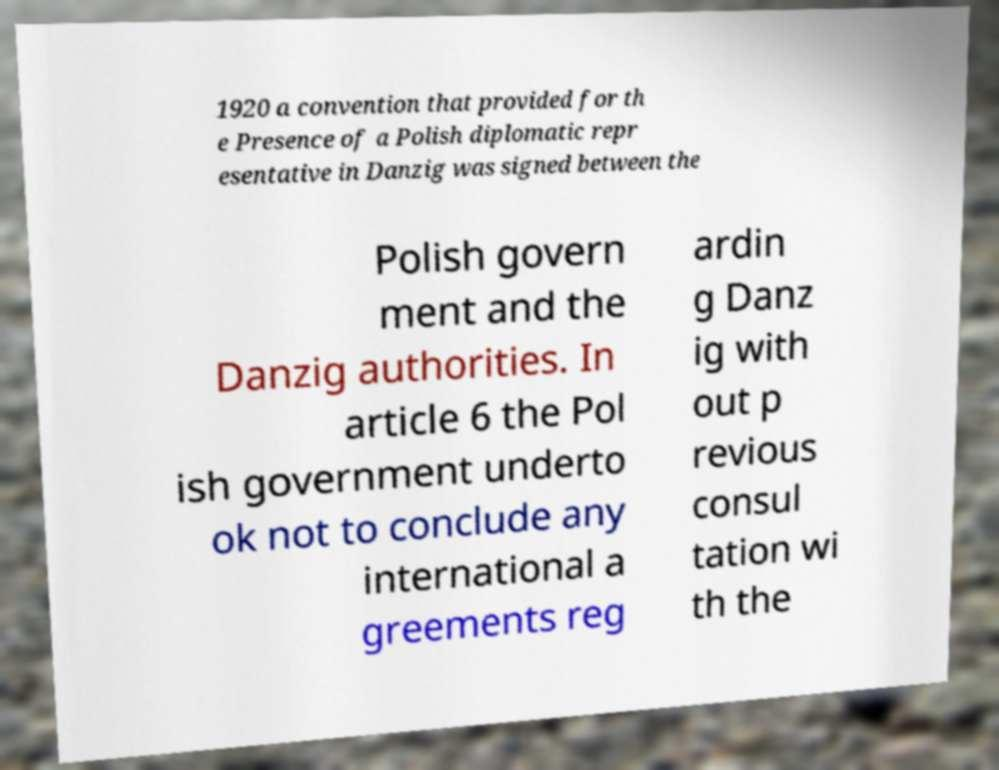For documentation purposes, I need the text within this image transcribed. Could you provide that? 1920 a convention that provided for th e Presence of a Polish diplomatic repr esentative in Danzig was signed between the Polish govern ment and the Danzig authorities. In article 6 the Pol ish government underto ok not to conclude any international a greements reg ardin g Danz ig with out p revious consul tation wi th the 